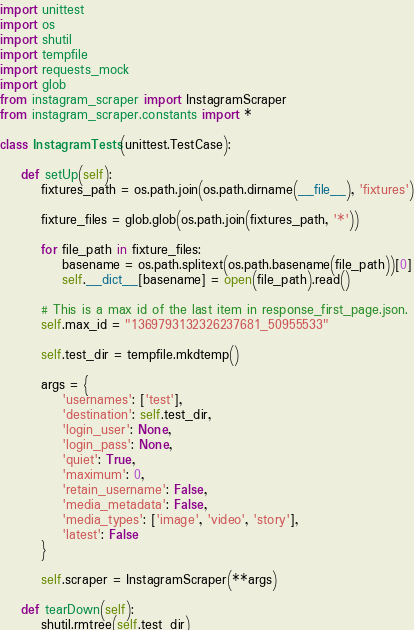Convert code to text. <code><loc_0><loc_0><loc_500><loc_500><_Python_>import unittest
import os
import shutil
import tempfile
import requests_mock
import glob
from instagram_scraper import InstagramScraper
from instagram_scraper.constants import *

class InstagramTests(unittest.TestCase):

    def setUp(self):
        fixtures_path = os.path.join(os.path.dirname(__file__), 'fixtures')

        fixture_files = glob.glob(os.path.join(fixtures_path, '*'))

        for file_path in fixture_files:
            basename = os.path.splitext(os.path.basename(file_path))[0]
            self.__dict__[basename] = open(file_path).read()

        # This is a max id of the last item in response_first_page.json.
        self.max_id = "1369793132326237681_50955533"

        self.test_dir = tempfile.mkdtemp()

        args = {
            'usernames': ['test'],
            'destination': self.test_dir,
            'login_user': None,
            'login_pass': None,
            'quiet': True,
            'maximum': 0,
            'retain_username': False,
            'media_metadata': False,
            'media_types': ['image', 'video', 'story'],
            'latest': False
        }

        self.scraper = InstagramScraper(**args)

    def tearDown(self):
        shutil.rmtree(self.test_dir)</code> 